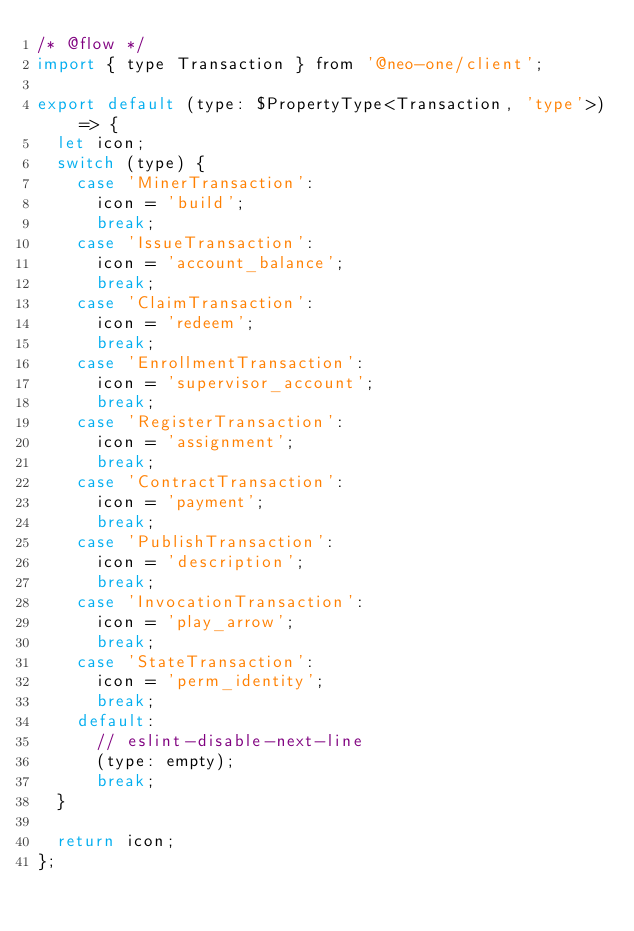<code> <loc_0><loc_0><loc_500><loc_500><_JavaScript_>/* @flow */
import { type Transaction } from '@neo-one/client';

export default (type: $PropertyType<Transaction, 'type'>) => {
  let icon;
  switch (type) {
    case 'MinerTransaction':
      icon = 'build';
      break;
    case 'IssueTransaction':
      icon = 'account_balance';
      break;
    case 'ClaimTransaction':
      icon = 'redeem';
      break;
    case 'EnrollmentTransaction':
      icon = 'supervisor_account';
      break;
    case 'RegisterTransaction':
      icon = 'assignment';
      break;
    case 'ContractTransaction':
      icon = 'payment';
      break;
    case 'PublishTransaction':
      icon = 'description';
      break;
    case 'InvocationTransaction':
      icon = 'play_arrow';
      break;
    case 'StateTransaction':
      icon = 'perm_identity';
      break;
    default:
      // eslint-disable-next-line
      (type: empty);
      break;
  }

  return icon;
};
</code> 